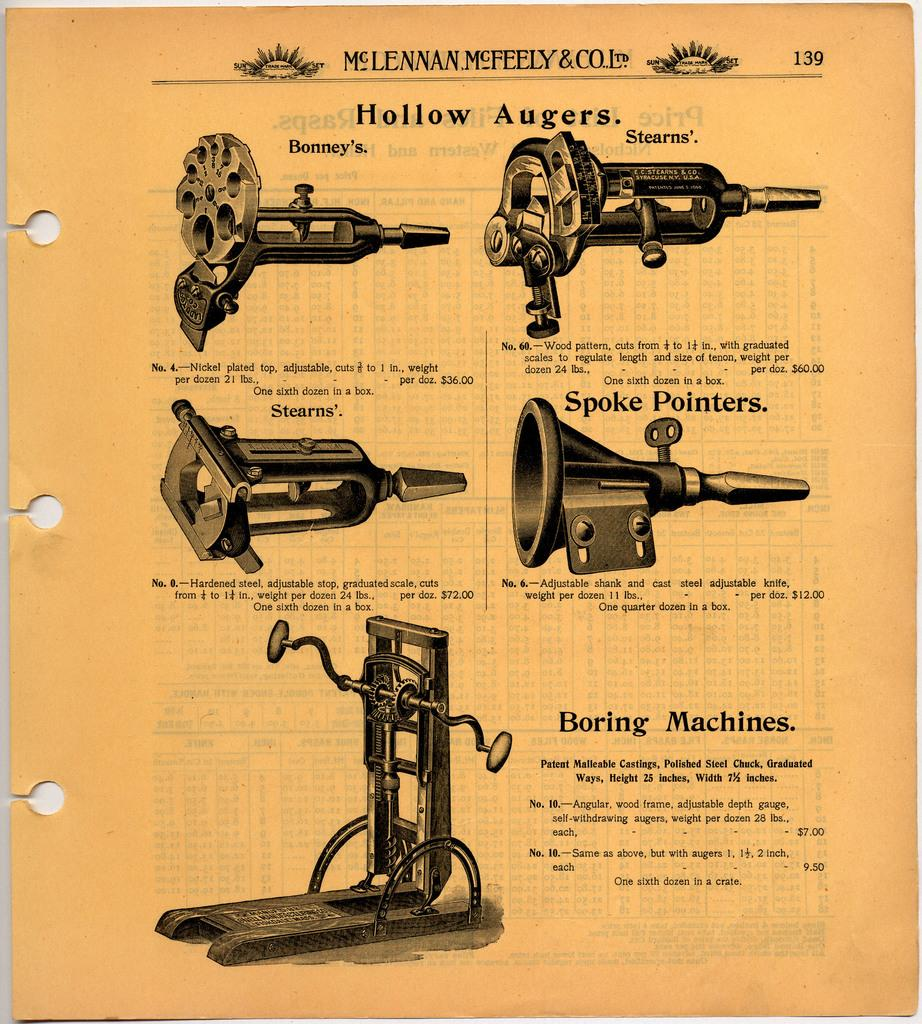What is present on the piece of paper in the image? The piece of paper has a page number and printed text on it. Can you describe the text on the piece of paper? Unfortunately, the specific content of the text cannot be determined from the image. What else can be seen in the image besides the piece of paper? There are objects visible in the image. How can you tell that the piece of paper is part of a larger document or book? The presence of a page number suggests that the piece of paper is part of a larger document or book. What type of punishment is being administered to the salt in the image? There is no salt or punishment present in the image. How does the piece of paper show respect to the reader in the image? The image does not provide any information about the content or context of the piece of paper, so it is impossible to determine whether it shows respect to the reader. 